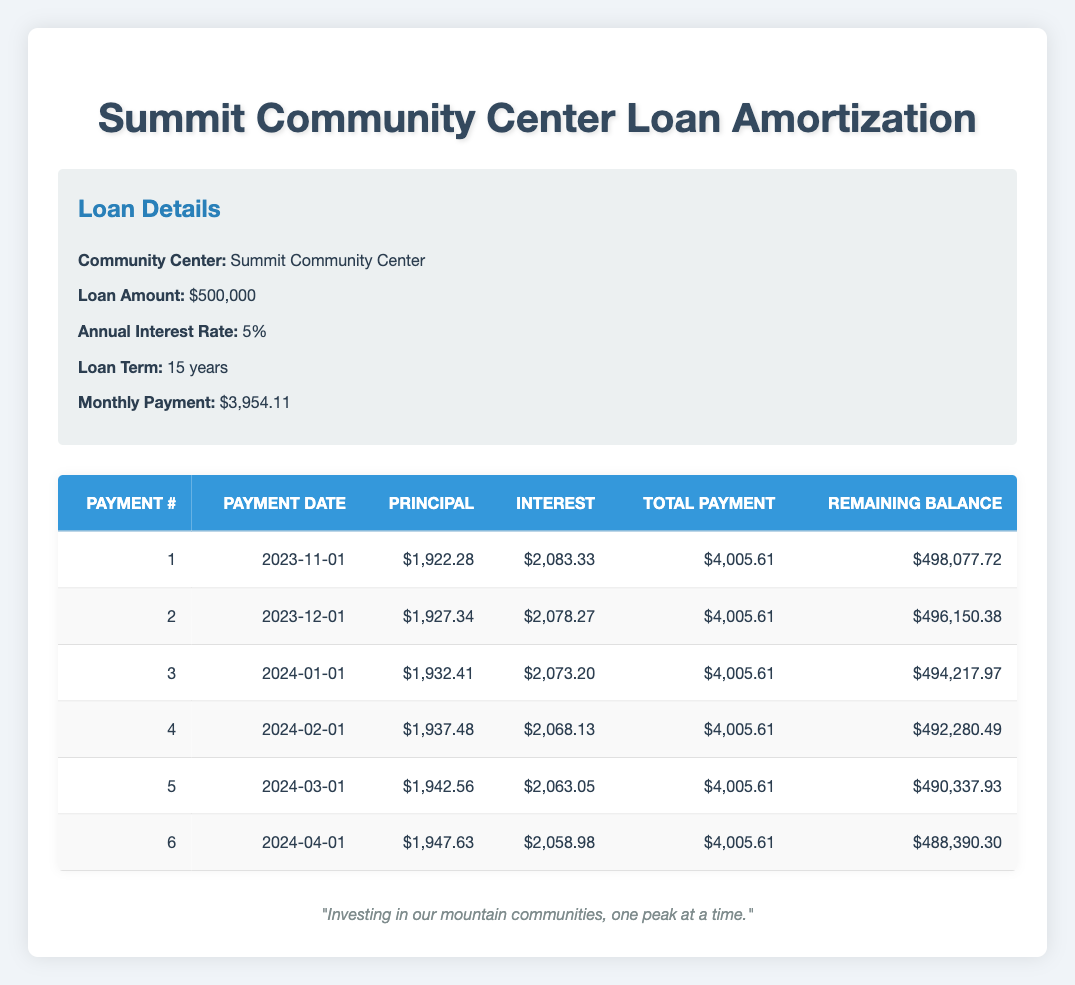What is the total amount of the loan taken for the Summit Community Center? The total loan amount is explicitly stated in the loan details section of the table. It is indicated as $500,000.
Answer: 500000 What was the payment amount for the first installment? The first installment's total payment can be found in the first row of the payment schedule, where it shows a total payment of $4,005.61.
Answer: 4005.61 How much principal is paid in the third payment? To find the principal payment for the third installment, we look at the third row in the table, which indicates a principal payment of $1,932.41.
Answer: 1932.41 Is it true that the interest payment for the second installment is greater than the interest payment for the first installment? In the second row, the interest payment is $2,078.27, and for the first row, it is $2,083.33. Since $2,078.27 is less than $2,083.33, the statement is false.
Answer: False What is the total principal paid after the first six payments? To find the total principal paid, we need to sum the principal payments of the first six rows: $1,922.28 + $1,927.34 + $1,932.41 + $1,937.48 + $1,942.56 + $1,947.63 = $11,709.70.
Answer: 11709.70 How much is the remaining balance after the fourth payment? The remaining balance is shown in the fourth row of the payment schedule, which states that after the fourth payment, the remaining balance is $492,280.49.
Answer: 492280.49 What is the average monthly payment over the first six payments? The monthly payment is consistent across all installments. Since each payment is $4,005.61, the average of the first six payments is also $4,005.61.
Answer: 4005.61 Is the interest payment in the sixth payment less than $2,059? In the sixth row, the interest payment is $2,058.98, which is indeed less than $2,059. Therefore, the statement is true.
Answer: True What is the difference in interest payments between the first and the last of the first six payments? The first payment's interest is $2,083.33 and the sixth payment's interest is $2,058.98. The difference can be calculated as $2,083.33 - $2,058.98 = $24.35.
Answer: 24.35 